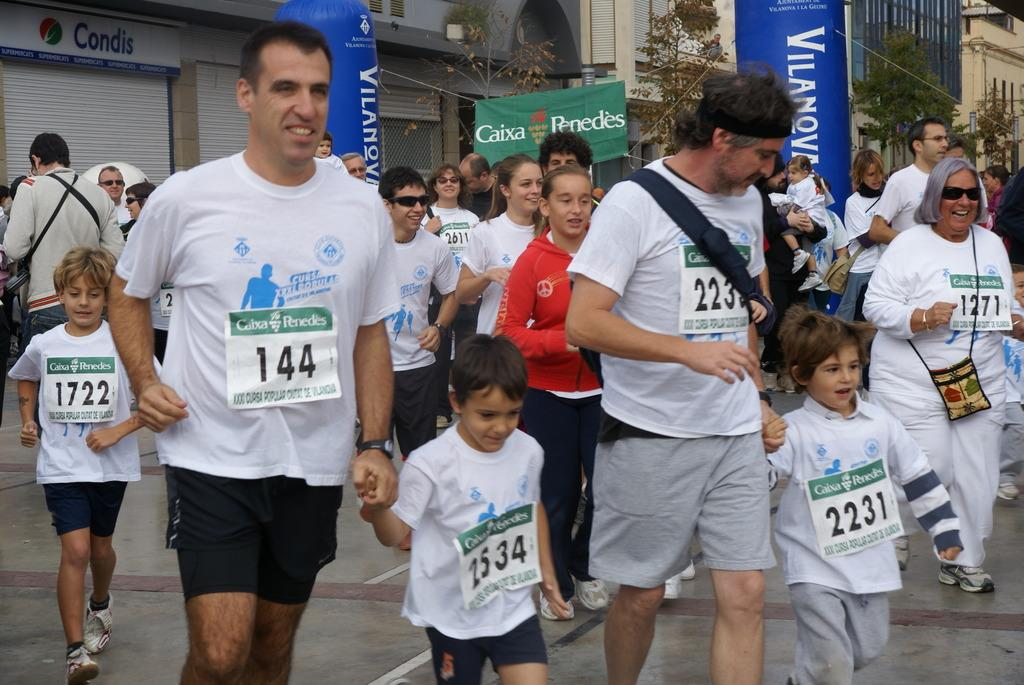What is the main subject of the image? The main subject of the image is a crowd. What can be seen in the background of the image? There are buildings, hoardings, and trees in the background of the image. How many lawyers are visible in the image? There is no mention of lawyers in the image, so it is impossible to determine their presence or number. 